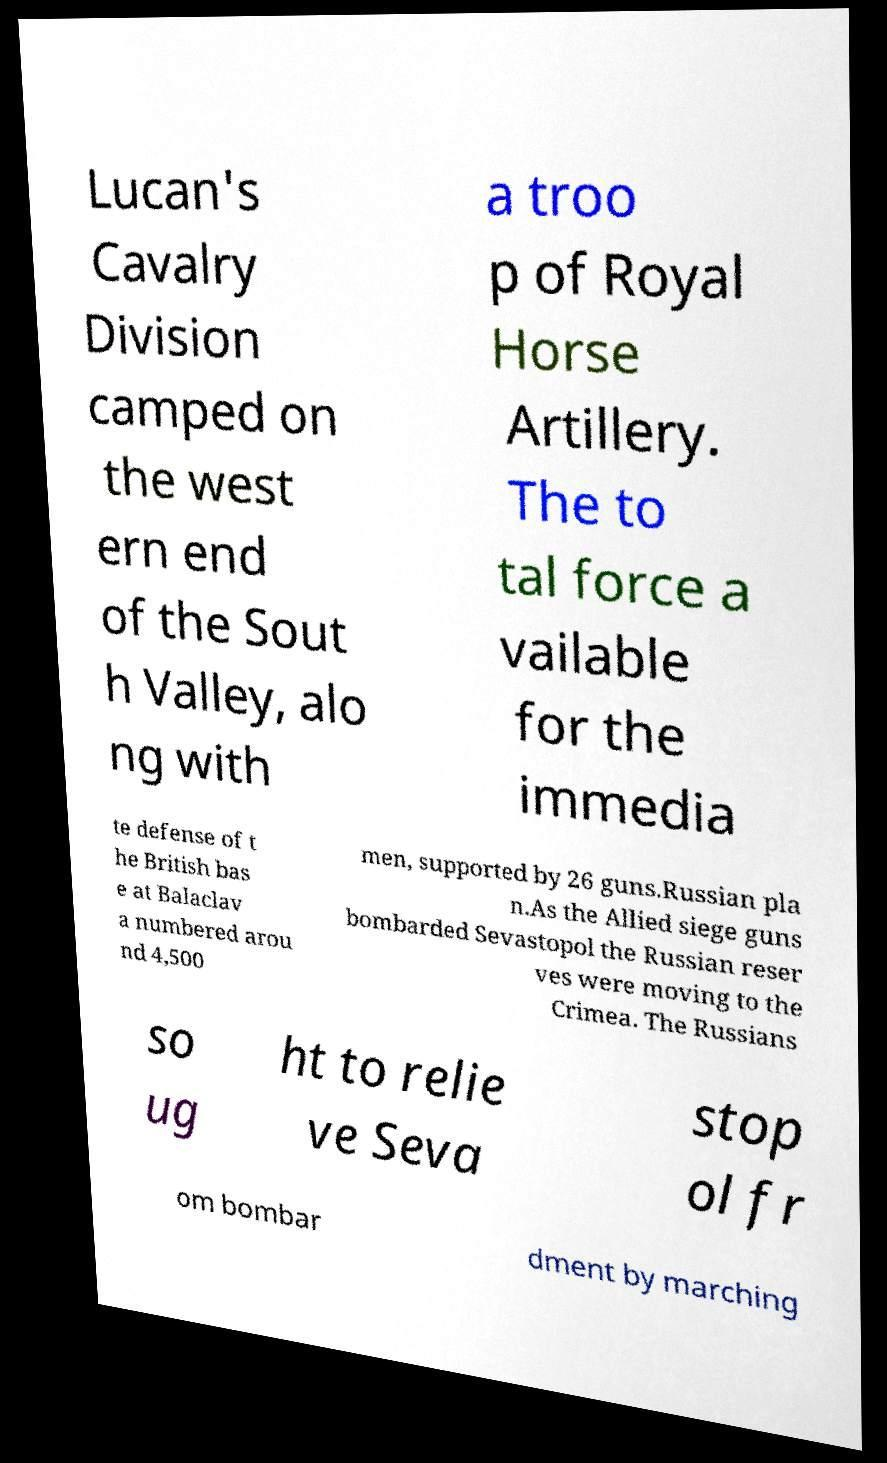What messages or text are displayed in this image? I need them in a readable, typed format. Lucan's Cavalry Division camped on the west ern end of the Sout h Valley, alo ng with a troo p of Royal Horse Artillery. The to tal force a vailable for the immedia te defense of t he British bas e at Balaclav a numbered arou nd 4,500 men, supported by 26 guns.Russian pla n.As the Allied siege guns bombarded Sevastopol the Russian reser ves were moving to the Crimea. The Russians so ug ht to relie ve Seva stop ol fr om bombar dment by marching 